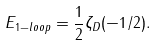Convert formula to latex. <formula><loc_0><loc_0><loc_500><loc_500>E _ { 1 - l o o p } = \frac { 1 } { 2 } \zeta _ { D } ( - 1 / 2 ) .</formula> 